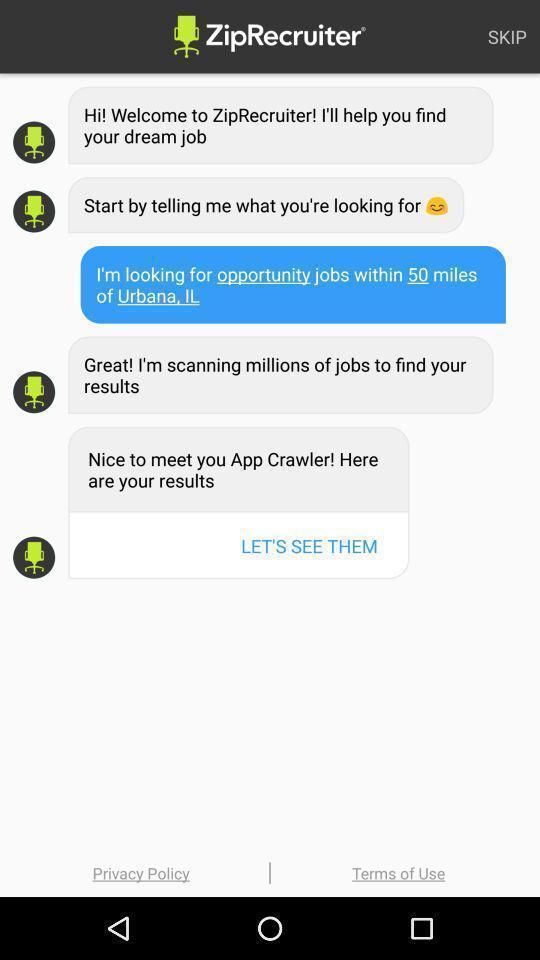Provide a detailed account of this screenshot. Display shows welcome messages in the job search app. 